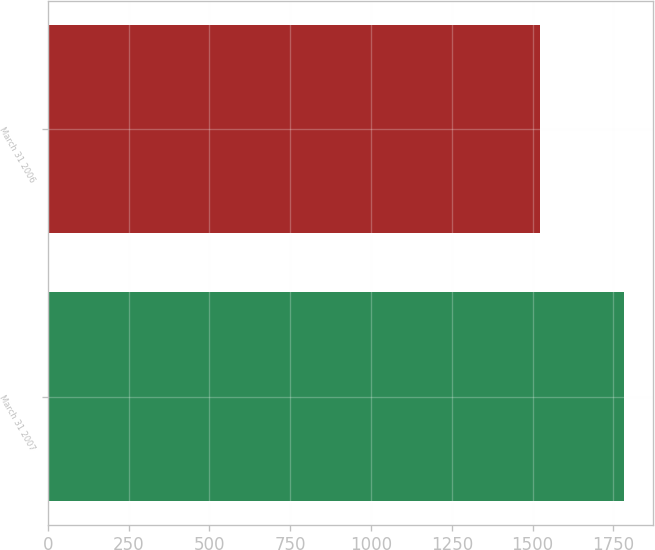<chart> <loc_0><loc_0><loc_500><loc_500><bar_chart><fcel>March 31 2007<fcel>March 31 2006<nl><fcel>1782<fcel>1523<nl></chart> 